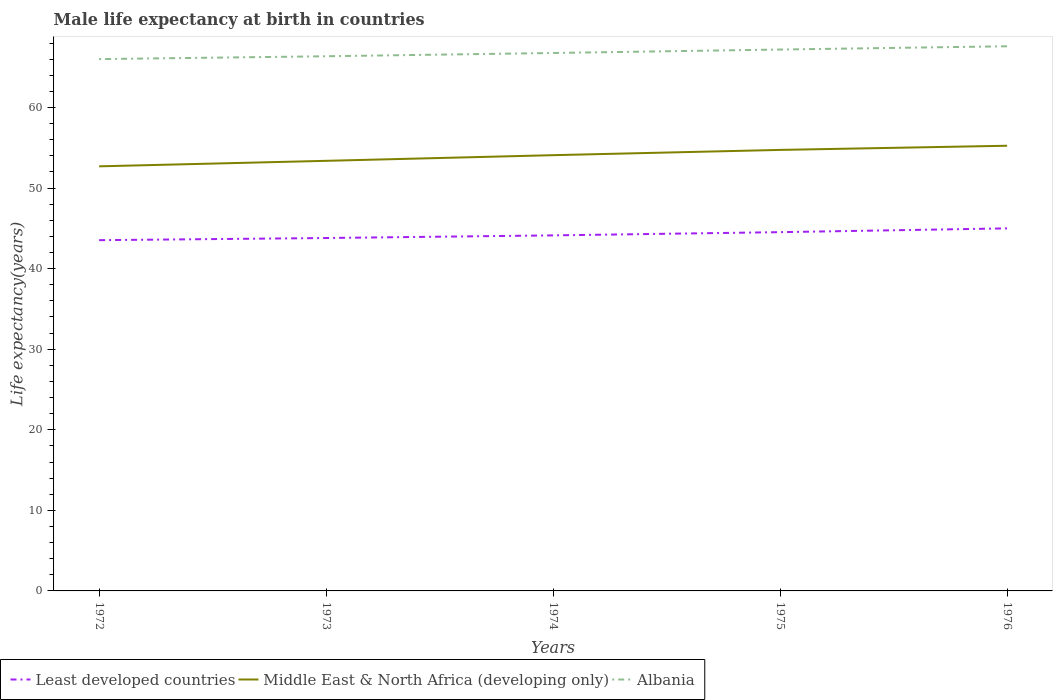Does the line corresponding to Middle East & North Africa (developing only) intersect with the line corresponding to Least developed countries?
Your response must be concise. No. Is the number of lines equal to the number of legend labels?
Offer a very short reply. Yes. Across all years, what is the maximum male life expectancy at birth in Least developed countries?
Make the answer very short. 43.53. What is the total male life expectancy at birth in Middle East & North Africa (developing only) in the graph?
Ensure brevity in your answer.  -0.7. What is the difference between the highest and the second highest male life expectancy at birth in Least developed countries?
Provide a short and direct response. 1.46. What is the difference between the highest and the lowest male life expectancy at birth in Least developed countries?
Provide a short and direct response. 2. How many years are there in the graph?
Give a very brief answer. 5. Are the values on the major ticks of Y-axis written in scientific E-notation?
Give a very brief answer. No. Does the graph contain grids?
Offer a very short reply. No. Where does the legend appear in the graph?
Your answer should be very brief. Bottom left. How many legend labels are there?
Make the answer very short. 3. What is the title of the graph?
Ensure brevity in your answer.  Male life expectancy at birth in countries. Does "Marshall Islands" appear as one of the legend labels in the graph?
Offer a terse response. No. What is the label or title of the Y-axis?
Give a very brief answer. Life expectancy(years). What is the Life expectancy(years) in Least developed countries in 1972?
Your answer should be very brief. 43.53. What is the Life expectancy(years) of Middle East & North Africa (developing only) in 1972?
Ensure brevity in your answer.  52.7. What is the Life expectancy(years) in Albania in 1972?
Your answer should be very brief. 66. What is the Life expectancy(years) of Least developed countries in 1973?
Provide a succinct answer. 43.8. What is the Life expectancy(years) in Middle East & North Africa (developing only) in 1973?
Offer a terse response. 53.38. What is the Life expectancy(years) in Albania in 1973?
Offer a terse response. 66.36. What is the Life expectancy(years) of Least developed countries in 1974?
Keep it short and to the point. 44.13. What is the Life expectancy(years) in Middle East & North Africa (developing only) in 1974?
Offer a very short reply. 54.08. What is the Life expectancy(years) of Albania in 1974?
Your answer should be compact. 66.76. What is the Life expectancy(years) of Least developed countries in 1975?
Ensure brevity in your answer.  44.53. What is the Life expectancy(years) in Middle East & North Africa (developing only) in 1975?
Offer a very short reply. 54.73. What is the Life expectancy(years) in Albania in 1975?
Offer a terse response. 67.19. What is the Life expectancy(years) in Least developed countries in 1976?
Keep it short and to the point. 45. What is the Life expectancy(years) of Middle East & North Africa (developing only) in 1976?
Your answer should be compact. 55.25. What is the Life expectancy(years) of Albania in 1976?
Provide a short and direct response. 67.6. Across all years, what is the maximum Life expectancy(years) in Least developed countries?
Keep it short and to the point. 45. Across all years, what is the maximum Life expectancy(years) in Middle East & North Africa (developing only)?
Your answer should be compact. 55.25. Across all years, what is the maximum Life expectancy(years) of Albania?
Your answer should be compact. 67.6. Across all years, what is the minimum Life expectancy(years) of Least developed countries?
Provide a succinct answer. 43.53. Across all years, what is the minimum Life expectancy(years) of Middle East & North Africa (developing only)?
Provide a succinct answer. 52.7. Across all years, what is the minimum Life expectancy(years) in Albania?
Keep it short and to the point. 66. What is the total Life expectancy(years) in Least developed countries in the graph?
Provide a succinct answer. 220.98. What is the total Life expectancy(years) of Middle East & North Africa (developing only) in the graph?
Provide a succinct answer. 270.14. What is the total Life expectancy(years) of Albania in the graph?
Make the answer very short. 333.91. What is the difference between the Life expectancy(years) of Least developed countries in 1972 and that in 1973?
Your answer should be compact. -0.27. What is the difference between the Life expectancy(years) in Middle East & North Africa (developing only) in 1972 and that in 1973?
Make the answer very short. -0.68. What is the difference between the Life expectancy(years) of Albania in 1972 and that in 1973?
Offer a terse response. -0.35. What is the difference between the Life expectancy(years) of Least developed countries in 1972 and that in 1974?
Provide a succinct answer. -0.59. What is the difference between the Life expectancy(years) in Middle East & North Africa (developing only) in 1972 and that in 1974?
Your answer should be very brief. -1.39. What is the difference between the Life expectancy(years) in Albania in 1972 and that in 1974?
Offer a very short reply. -0.76. What is the difference between the Life expectancy(years) in Least developed countries in 1972 and that in 1975?
Your answer should be compact. -0.99. What is the difference between the Life expectancy(years) in Middle East & North Africa (developing only) in 1972 and that in 1975?
Offer a terse response. -2.04. What is the difference between the Life expectancy(years) of Albania in 1972 and that in 1975?
Provide a short and direct response. -1.19. What is the difference between the Life expectancy(years) of Least developed countries in 1972 and that in 1976?
Provide a succinct answer. -1.46. What is the difference between the Life expectancy(years) of Middle East & North Africa (developing only) in 1972 and that in 1976?
Give a very brief answer. -2.55. What is the difference between the Life expectancy(years) of Albania in 1972 and that in 1976?
Ensure brevity in your answer.  -1.59. What is the difference between the Life expectancy(years) of Least developed countries in 1973 and that in 1974?
Keep it short and to the point. -0.33. What is the difference between the Life expectancy(years) in Middle East & North Africa (developing only) in 1973 and that in 1974?
Provide a succinct answer. -0.7. What is the difference between the Life expectancy(years) of Albania in 1973 and that in 1974?
Offer a very short reply. -0.41. What is the difference between the Life expectancy(years) of Least developed countries in 1973 and that in 1975?
Provide a short and direct response. -0.73. What is the difference between the Life expectancy(years) in Middle East & North Africa (developing only) in 1973 and that in 1975?
Provide a succinct answer. -1.36. What is the difference between the Life expectancy(years) of Albania in 1973 and that in 1975?
Give a very brief answer. -0.83. What is the difference between the Life expectancy(years) of Least developed countries in 1973 and that in 1976?
Your answer should be compact. -1.2. What is the difference between the Life expectancy(years) of Middle East & North Africa (developing only) in 1973 and that in 1976?
Offer a terse response. -1.87. What is the difference between the Life expectancy(years) of Albania in 1973 and that in 1976?
Give a very brief answer. -1.24. What is the difference between the Life expectancy(years) in Least developed countries in 1974 and that in 1975?
Your answer should be very brief. -0.4. What is the difference between the Life expectancy(years) in Middle East & North Africa (developing only) in 1974 and that in 1975?
Your answer should be compact. -0.65. What is the difference between the Life expectancy(years) in Albania in 1974 and that in 1975?
Your response must be concise. -0.43. What is the difference between the Life expectancy(years) of Least developed countries in 1974 and that in 1976?
Offer a terse response. -0.87. What is the difference between the Life expectancy(years) in Middle East & North Africa (developing only) in 1974 and that in 1976?
Make the answer very short. -1.17. What is the difference between the Life expectancy(years) in Albania in 1974 and that in 1976?
Give a very brief answer. -0.83. What is the difference between the Life expectancy(years) of Least developed countries in 1975 and that in 1976?
Ensure brevity in your answer.  -0.47. What is the difference between the Life expectancy(years) of Middle East & North Africa (developing only) in 1975 and that in 1976?
Offer a very short reply. -0.52. What is the difference between the Life expectancy(years) in Albania in 1975 and that in 1976?
Your response must be concise. -0.41. What is the difference between the Life expectancy(years) of Least developed countries in 1972 and the Life expectancy(years) of Middle East & North Africa (developing only) in 1973?
Provide a succinct answer. -9.85. What is the difference between the Life expectancy(years) in Least developed countries in 1972 and the Life expectancy(years) in Albania in 1973?
Ensure brevity in your answer.  -22.82. What is the difference between the Life expectancy(years) in Middle East & North Africa (developing only) in 1972 and the Life expectancy(years) in Albania in 1973?
Your response must be concise. -13.66. What is the difference between the Life expectancy(years) in Least developed countries in 1972 and the Life expectancy(years) in Middle East & North Africa (developing only) in 1974?
Make the answer very short. -10.55. What is the difference between the Life expectancy(years) of Least developed countries in 1972 and the Life expectancy(years) of Albania in 1974?
Offer a very short reply. -23.23. What is the difference between the Life expectancy(years) of Middle East & North Africa (developing only) in 1972 and the Life expectancy(years) of Albania in 1974?
Provide a succinct answer. -14.07. What is the difference between the Life expectancy(years) in Least developed countries in 1972 and the Life expectancy(years) in Middle East & North Africa (developing only) in 1975?
Make the answer very short. -11.2. What is the difference between the Life expectancy(years) of Least developed countries in 1972 and the Life expectancy(years) of Albania in 1975?
Make the answer very short. -23.66. What is the difference between the Life expectancy(years) in Middle East & North Africa (developing only) in 1972 and the Life expectancy(years) in Albania in 1975?
Your answer should be compact. -14.49. What is the difference between the Life expectancy(years) in Least developed countries in 1972 and the Life expectancy(years) in Middle East & North Africa (developing only) in 1976?
Provide a short and direct response. -11.72. What is the difference between the Life expectancy(years) in Least developed countries in 1972 and the Life expectancy(years) in Albania in 1976?
Give a very brief answer. -24.06. What is the difference between the Life expectancy(years) in Middle East & North Africa (developing only) in 1972 and the Life expectancy(years) in Albania in 1976?
Make the answer very short. -14.9. What is the difference between the Life expectancy(years) of Least developed countries in 1973 and the Life expectancy(years) of Middle East & North Africa (developing only) in 1974?
Offer a terse response. -10.28. What is the difference between the Life expectancy(years) in Least developed countries in 1973 and the Life expectancy(years) in Albania in 1974?
Offer a very short reply. -22.96. What is the difference between the Life expectancy(years) of Middle East & North Africa (developing only) in 1973 and the Life expectancy(years) of Albania in 1974?
Provide a short and direct response. -13.38. What is the difference between the Life expectancy(years) of Least developed countries in 1973 and the Life expectancy(years) of Middle East & North Africa (developing only) in 1975?
Your response must be concise. -10.94. What is the difference between the Life expectancy(years) of Least developed countries in 1973 and the Life expectancy(years) of Albania in 1975?
Offer a terse response. -23.39. What is the difference between the Life expectancy(years) in Middle East & North Africa (developing only) in 1973 and the Life expectancy(years) in Albania in 1975?
Your response must be concise. -13.81. What is the difference between the Life expectancy(years) in Least developed countries in 1973 and the Life expectancy(years) in Middle East & North Africa (developing only) in 1976?
Keep it short and to the point. -11.45. What is the difference between the Life expectancy(years) in Least developed countries in 1973 and the Life expectancy(years) in Albania in 1976?
Your response must be concise. -23.8. What is the difference between the Life expectancy(years) in Middle East & North Africa (developing only) in 1973 and the Life expectancy(years) in Albania in 1976?
Ensure brevity in your answer.  -14.22. What is the difference between the Life expectancy(years) of Least developed countries in 1974 and the Life expectancy(years) of Middle East & North Africa (developing only) in 1975?
Provide a short and direct response. -10.61. What is the difference between the Life expectancy(years) in Least developed countries in 1974 and the Life expectancy(years) in Albania in 1975?
Provide a short and direct response. -23.06. What is the difference between the Life expectancy(years) in Middle East & North Africa (developing only) in 1974 and the Life expectancy(years) in Albania in 1975?
Ensure brevity in your answer.  -13.11. What is the difference between the Life expectancy(years) of Least developed countries in 1974 and the Life expectancy(years) of Middle East & North Africa (developing only) in 1976?
Your response must be concise. -11.12. What is the difference between the Life expectancy(years) of Least developed countries in 1974 and the Life expectancy(years) of Albania in 1976?
Make the answer very short. -23.47. What is the difference between the Life expectancy(years) in Middle East & North Africa (developing only) in 1974 and the Life expectancy(years) in Albania in 1976?
Offer a very short reply. -13.51. What is the difference between the Life expectancy(years) in Least developed countries in 1975 and the Life expectancy(years) in Middle East & North Africa (developing only) in 1976?
Give a very brief answer. -10.72. What is the difference between the Life expectancy(years) of Least developed countries in 1975 and the Life expectancy(years) of Albania in 1976?
Ensure brevity in your answer.  -23.07. What is the difference between the Life expectancy(years) in Middle East & North Africa (developing only) in 1975 and the Life expectancy(years) in Albania in 1976?
Your answer should be very brief. -12.86. What is the average Life expectancy(years) of Least developed countries per year?
Offer a very short reply. 44.2. What is the average Life expectancy(years) in Middle East & North Africa (developing only) per year?
Your response must be concise. 54.03. What is the average Life expectancy(years) in Albania per year?
Provide a short and direct response. 66.78. In the year 1972, what is the difference between the Life expectancy(years) in Least developed countries and Life expectancy(years) in Middle East & North Africa (developing only)?
Provide a succinct answer. -9.16. In the year 1972, what is the difference between the Life expectancy(years) of Least developed countries and Life expectancy(years) of Albania?
Give a very brief answer. -22.47. In the year 1972, what is the difference between the Life expectancy(years) of Middle East & North Africa (developing only) and Life expectancy(years) of Albania?
Provide a succinct answer. -13.31. In the year 1973, what is the difference between the Life expectancy(years) of Least developed countries and Life expectancy(years) of Middle East & North Africa (developing only)?
Ensure brevity in your answer.  -9.58. In the year 1973, what is the difference between the Life expectancy(years) of Least developed countries and Life expectancy(years) of Albania?
Your answer should be compact. -22.56. In the year 1973, what is the difference between the Life expectancy(years) in Middle East & North Africa (developing only) and Life expectancy(years) in Albania?
Keep it short and to the point. -12.98. In the year 1974, what is the difference between the Life expectancy(years) of Least developed countries and Life expectancy(years) of Middle East & North Africa (developing only)?
Offer a very short reply. -9.96. In the year 1974, what is the difference between the Life expectancy(years) in Least developed countries and Life expectancy(years) in Albania?
Give a very brief answer. -22.64. In the year 1974, what is the difference between the Life expectancy(years) in Middle East & North Africa (developing only) and Life expectancy(years) in Albania?
Give a very brief answer. -12.68. In the year 1975, what is the difference between the Life expectancy(years) of Least developed countries and Life expectancy(years) of Middle East & North Africa (developing only)?
Provide a succinct answer. -10.21. In the year 1975, what is the difference between the Life expectancy(years) of Least developed countries and Life expectancy(years) of Albania?
Give a very brief answer. -22.66. In the year 1975, what is the difference between the Life expectancy(years) of Middle East & North Africa (developing only) and Life expectancy(years) of Albania?
Provide a succinct answer. -12.46. In the year 1976, what is the difference between the Life expectancy(years) in Least developed countries and Life expectancy(years) in Middle East & North Africa (developing only)?
Provide a succinct answer. -10.25. In the year 1976, what is the difference between the Life expectancy(years) of Least developed countries and Life expectancy(years) of Albania?
Keep it short and to the point. -22.6. In the year 1976, what is the difference between the Life expectancy(years) of Middle East & North Africa (developing only) and Life expectancy(years) of Albania?
Keep it short and to the point. -12.35. What is the ratio of the Life expectancy(years) in Middle East & North Africa (developing only) in 1972 to that in 1973?
Offer a terse response. 0.99. What is the ratio of the Life expectancy(years) in Albania in 1972 to that in 1973?
Keep it short and to the point. 0.99. What is the ratio of the Life expectancy(years) in Least developed countries in 1972 to that in 1974?
Your answer should be compact. 0.99. What is the ratio of the Life expectancy(years) in Middle East & North Africa (developing only) in 1972 to that in 1974?
Offer a very short reply. 0.97. What is the ratio of the Life expectancy(years) of Least developed countries in 1972 to that in 1975?
Your answer should be compact. 0.98. What is the ratio of the Life expectancy(years) of Middle East & North Africa (developing only) in 1972 to that in 1975?
Your answer should be very brief. 0.96. What is the ratio of the Life expectancy(years) in Albania in 1972 to that in 1975?
Make the answer very short. 0.98. What is the ratio of the Life expectancy(years) in Least developed countries in 1972 to that in 1976?
Keep it short and to the point. 0.97. What is the ratio of the Life expectancy(years) of Middle East & North Africa (developing only) in 1972 to that in 1976?
Your answer should be very brief. 0.95. What is the ratio of the Life expectancy(years) of Albania in 1972 to that in 1976?
Provide a short and direct response. 0.98. What is the ratio of the Life expectancy(years) of Least developed countries in 1973 to that in 1974?
Your answer should be very brief. 0.99. What is the ratio of the Life expectancy(years) of Albania in 1973 to that in 1974?
Your response must be concise. 0.99. What is the ratio of the Life expectancy(years) of Least developed countries in 1973 to that in 1975?
Keep it short and to the point. 0.98. What is the ratio of the Life expectancy(years) of Middle East & North Africa (developing only) in 1973 to that in 1975?
Ensure brevity in your answer.  0.98. What is the ratio of the Life expectancy(years) in Albania in 1973 to that in 1975?
Offer a terse response. 0.99. What is the ratio of the Life expectancy(years) in Least developed countries in 1973 to that in 1976?
Provide a short and direct response. 0.97. What is the ratio of the Life expectancy(years) of Middle East & North Africa (developing only) in 1973 to that in 1976?
Provide a succinct answer. 0.97. What is the ratio of the Life expectancy(years) in Albania in 1973 to that in 1976?
Provide a short and direct response. 0.98. What is the ratio of the Life expectancy(years) in Middle East & North Africa (developing only) in 1974 to that in 1975?
Make the answer very short. 0.99. What is the ratio of the Life expectancy(years) of Least developed countries in 1974 to that in 1976?
Make the answer very short. 0.98. What is the ratio of the Life expectancy(years) of Middle East & North Africa (developing only) in 1974 to that in 1976?
Your answer should be very brief. 0.98. What is the ratio of the Life expectancy(years) of Albania in 1975 to that in 1976?
Your response must be concise. 0.99. What is the difference between the highest and the second highest Life expectancy(years) of Least developed countries?
Your answer should be compact. 0.47. What is the difference between the highest and the second highest Life expectancy(years) in Middle East & North Africa (developing only)?
Provide a succinct answer. 0.52. What is the difference between the highest and the second highest Life expectancy(years) in Albania?
Make the answer very short. 0.41. What is the difference between the highest and the lowest Life expectancy(years) of Least developed countries?
Your answer should be compact. 1.46. What is the difference between the highest and the lowest Life expectancy(years) of Middle East & North Africa (developing only)?
Offer a terse response. 2.55. What is the difference between the highest and the lowest Life expectancy(years) in Albania?
Make the answer very short. 1.59. 